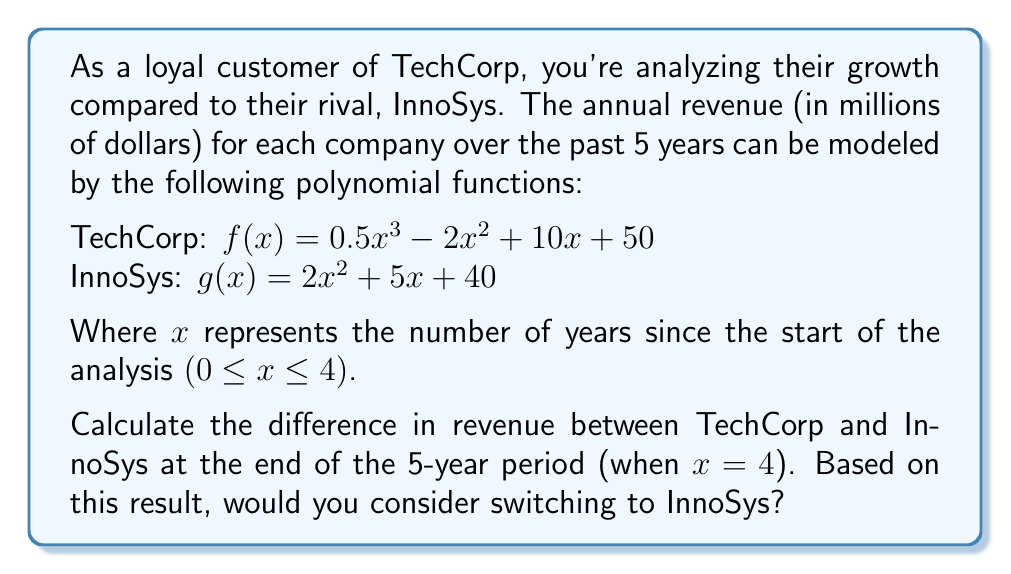Solve this math problem. To solve this problem, we need to follow these steps:

1. Calculate the revenue for TechCorp when x = 4:
   $f(4) = 0.5(4^3) - 2(4^2) + 10(4) + 50$
   $= 0.5(64) - 2(16) + 40 + 50$
   $= 32 - 32 + 40 + 50$
   $= 90$ million dollars

2. Calculate the revenue for InnoSys when x = 4:
   $g(4) = 2(4^2) + 5(4) + 40$
   $= 2(16) + 20 + 40$
   $= 32 + 20 + 40$
   $= 92$ million dollars

3. Calculate the difference in revenue:
   Difference = InnoSys revenue - TechCorp revenue
   $= 92 - 90 = 2$ million dollars

4. Interpret the result:
   InnoSys has a higher revenue by $2 million at the end of the 5-year period. However, as a loyal customer who values reliable service, this small difference may not be significant enough to warrant switching companies. Additionally, TechCorp's revenue function is a cubic polynomial, which may indicate potential for faster growth in the future compared to InnoSys's quadratic growth.
Answer: The difference in revenue between InnoSys and TechCorp at the end of the 5-year period is $2 million in favor of InnoSys. However, given the small difference and the potential for faster future growth with TechCorp, switching to InnoSys may not be advisable for a loyal customer who values reliable service. 